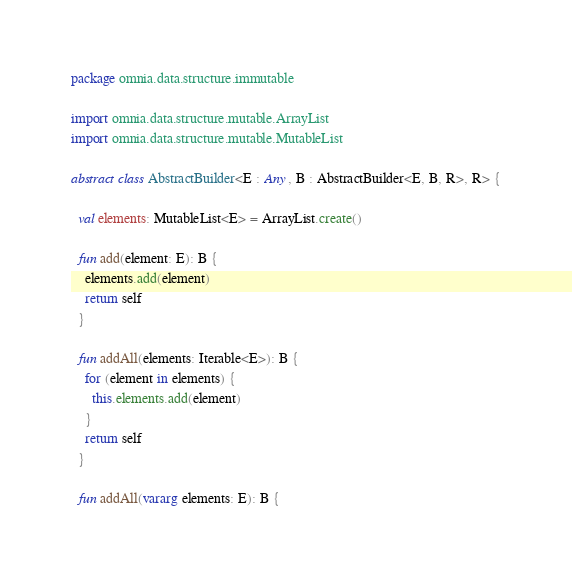Convert code to text. <code><loc_0><loc_0><loc_500><loc_500><_Kotlin_>package omnia.data.structure.immutable

import omnia.data.structure.mutable.ArrayList
import omnia.data.structure.mutable.MutableList

abstract class AbstractBuilder<E : Any, B : AbstractBuilder<E, B, R>, R> {

  val elements: MutableList<E> = ArrayList.create()

  fun add(element: E): B {
    elements.add(element)
    return self
  }

  fun addAll(elements: Iterable<E>): B {
    for (element in elements) {
      this.elements.add(element)
    }
    return self
  }

  fun addAll(vararg elements: E): B {</code> 